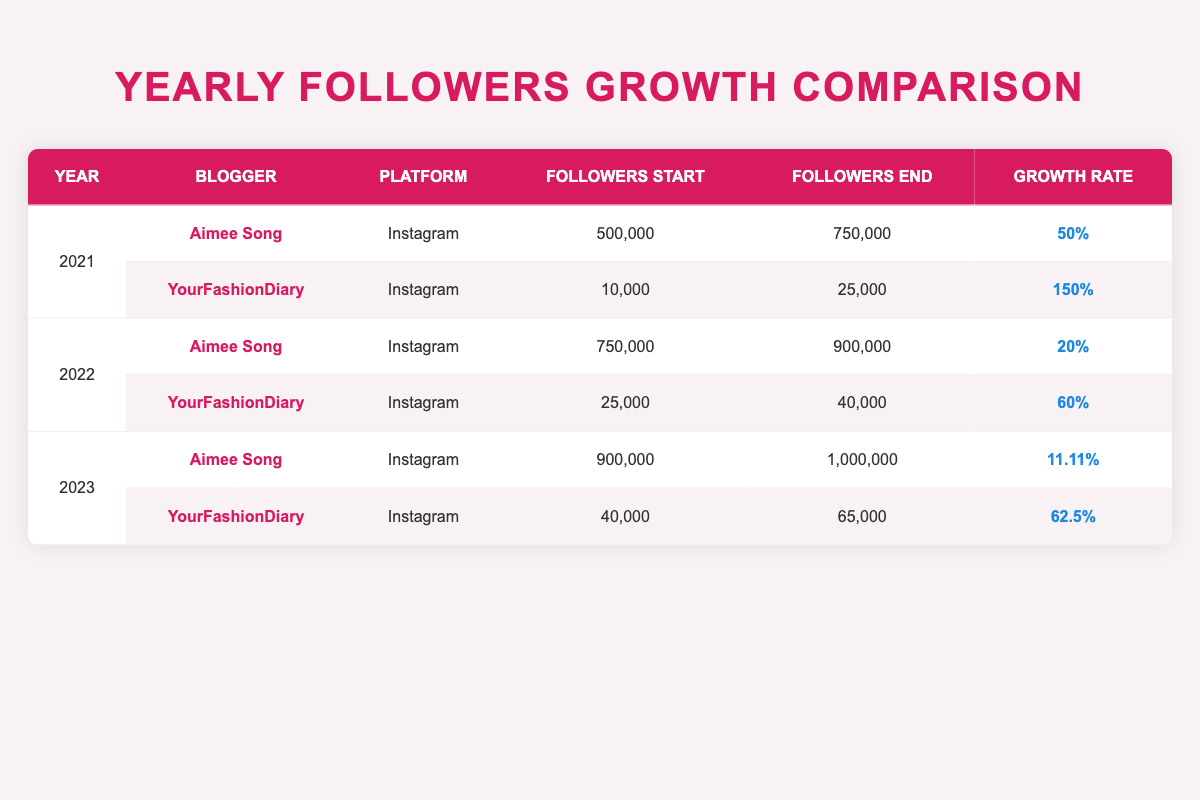What was the growth rate for YourFashionDiary in 2021? The table indicates that YourFashionDiary had a growth rate of 150% in 2021. This is found in the row corresponding to the year 2021, under the growth rate column for YourFashionDiary.
Answer: 150% Which blogger had the highest total followers at the end of 2022? According to the table, at the end of 2022, Aimee Song had 900,000 followers and YourFashionDiary had 40,000 followers. Thus, Aimee Song had the highest total followers.
Answer: Aimee Song What was the average growth rate for both bloggers in 2023? For 2023, Aimee Song had a growth rate of 11.11% and YourFashionDiary had 62.5%. Adding these gives 11.11 + 62.5 = 73.61. To find the average, divide by 2: 73.61 / 2 = 36.805.
Answer: 36.805% Did YourFashionDiary have a higher growth rate than Aimee Song in 2022? Yes, according to the table, YourFashionDiary had a growth rate of 60% while Aimee Song had a growth rate of 20% in 2022.
Answer: Yes What is the total number of followers gained by YourFashionDiary from 2021 to 2023? From 2021 to 2023, YourFashionDiary started with 10,000 followers in 2021 and ended with 65,000 in 2023. The total gained is calculated as follows: 65,000 - 10,000 = 55,000.
Answer: 55,000 In which year did Aimee Song experience the lowest growth rate, and what was that rate? In reviewing the table, Aimee Song had the lowest growth rate of 11.11% in 2023, as this is the smallest value in the growth rate column for Aimee Song across all years.
Answer: 2023, 11.11% 